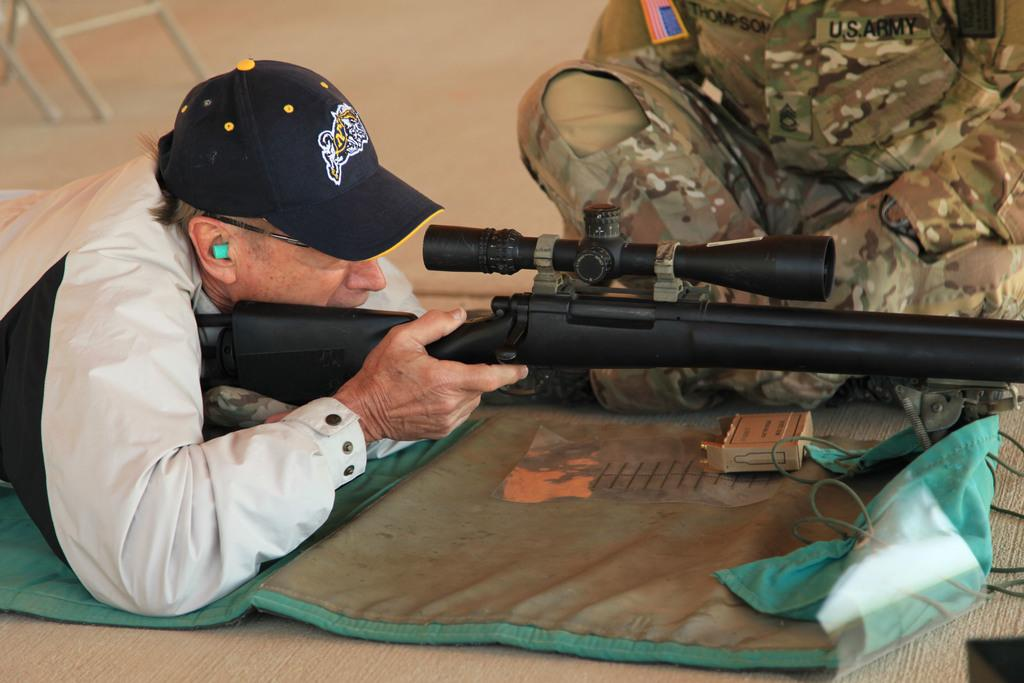What is the person in the image holding? The person in the image is holding a machine gun. What type of clothing is the other person wearing? The other person is wearing a uniform. Where is the person in the uniform sitting? The person in the uniform is sitting on a surface on the right side of the image. What shape is the toad in the image? There is no toad present in the image. What grade is the person in the uniform in? The provided facts do not mention the person's grade or level of education. 